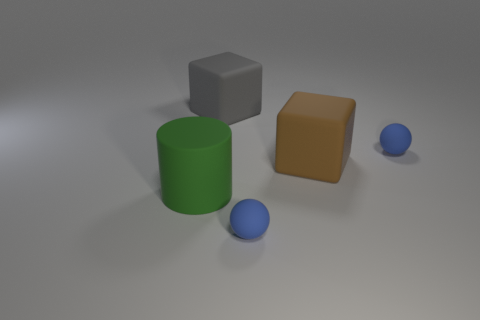How many small blue rubber things are the same shape as the brown object?
Provide a short and direct response. 0. Are there more green cylinders that are behind the large green rubber cylinder than big green things?
Provide a succinct answer. No. There is a blue rubber thing in front of the large matte thing that is on the left side of the cube that is on the left side of the big brown thing; what is its shape?
Provide a succinct answer. Sphere. There is a small thing that is on the left side of the brown matte object; is its shape the same as the blue thing behind the large green object?
Your answer should be compact. Yes. Are there any other things that have the same size as the brown thing?
Ensure brevity in your answer.  Yes. How many cylinders are big brown rubber objects or tiny blue things?
Keep it short and to the point. 0. Is the big green thing made of the same material as the brown object?
Provide a succinct answer. Yes. How many other objects are the same color as the cylinder?
Your response must be concise. 0. There is a matte thing that is left of the gray thing; what is its shape?
Offer a terse response. Cylinder. How many things are big objects or green matte things?
Your answer should be very brief. 3. 